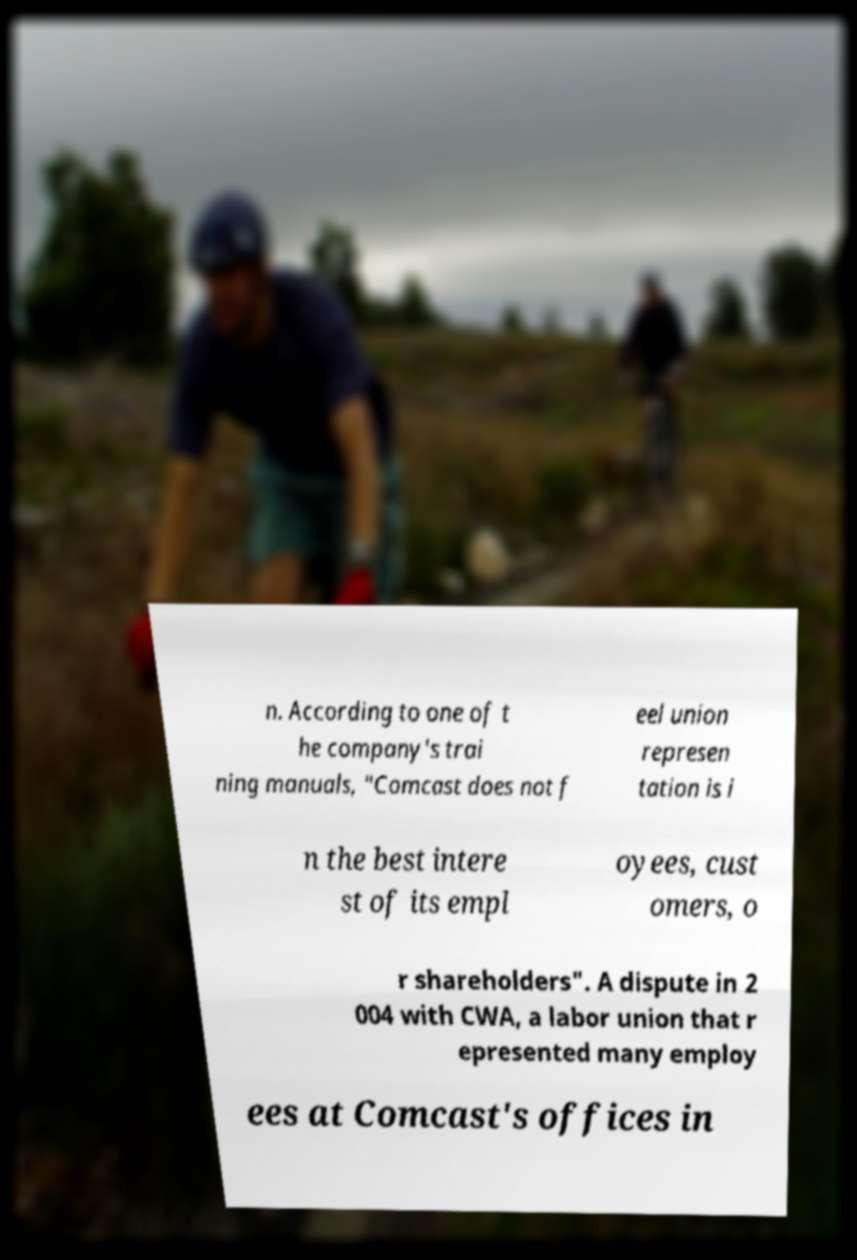Could you extract and type out the text from this image? n. According to one of t he company's trai ning manuals, "Comcast does not f eel union represen tation is i n the best intere st of its empl oyees, cust omers, o r shareholders". A dispute in 2 004 with CWA, a labor union that r epresented many employ ees at Comcast's offices in 